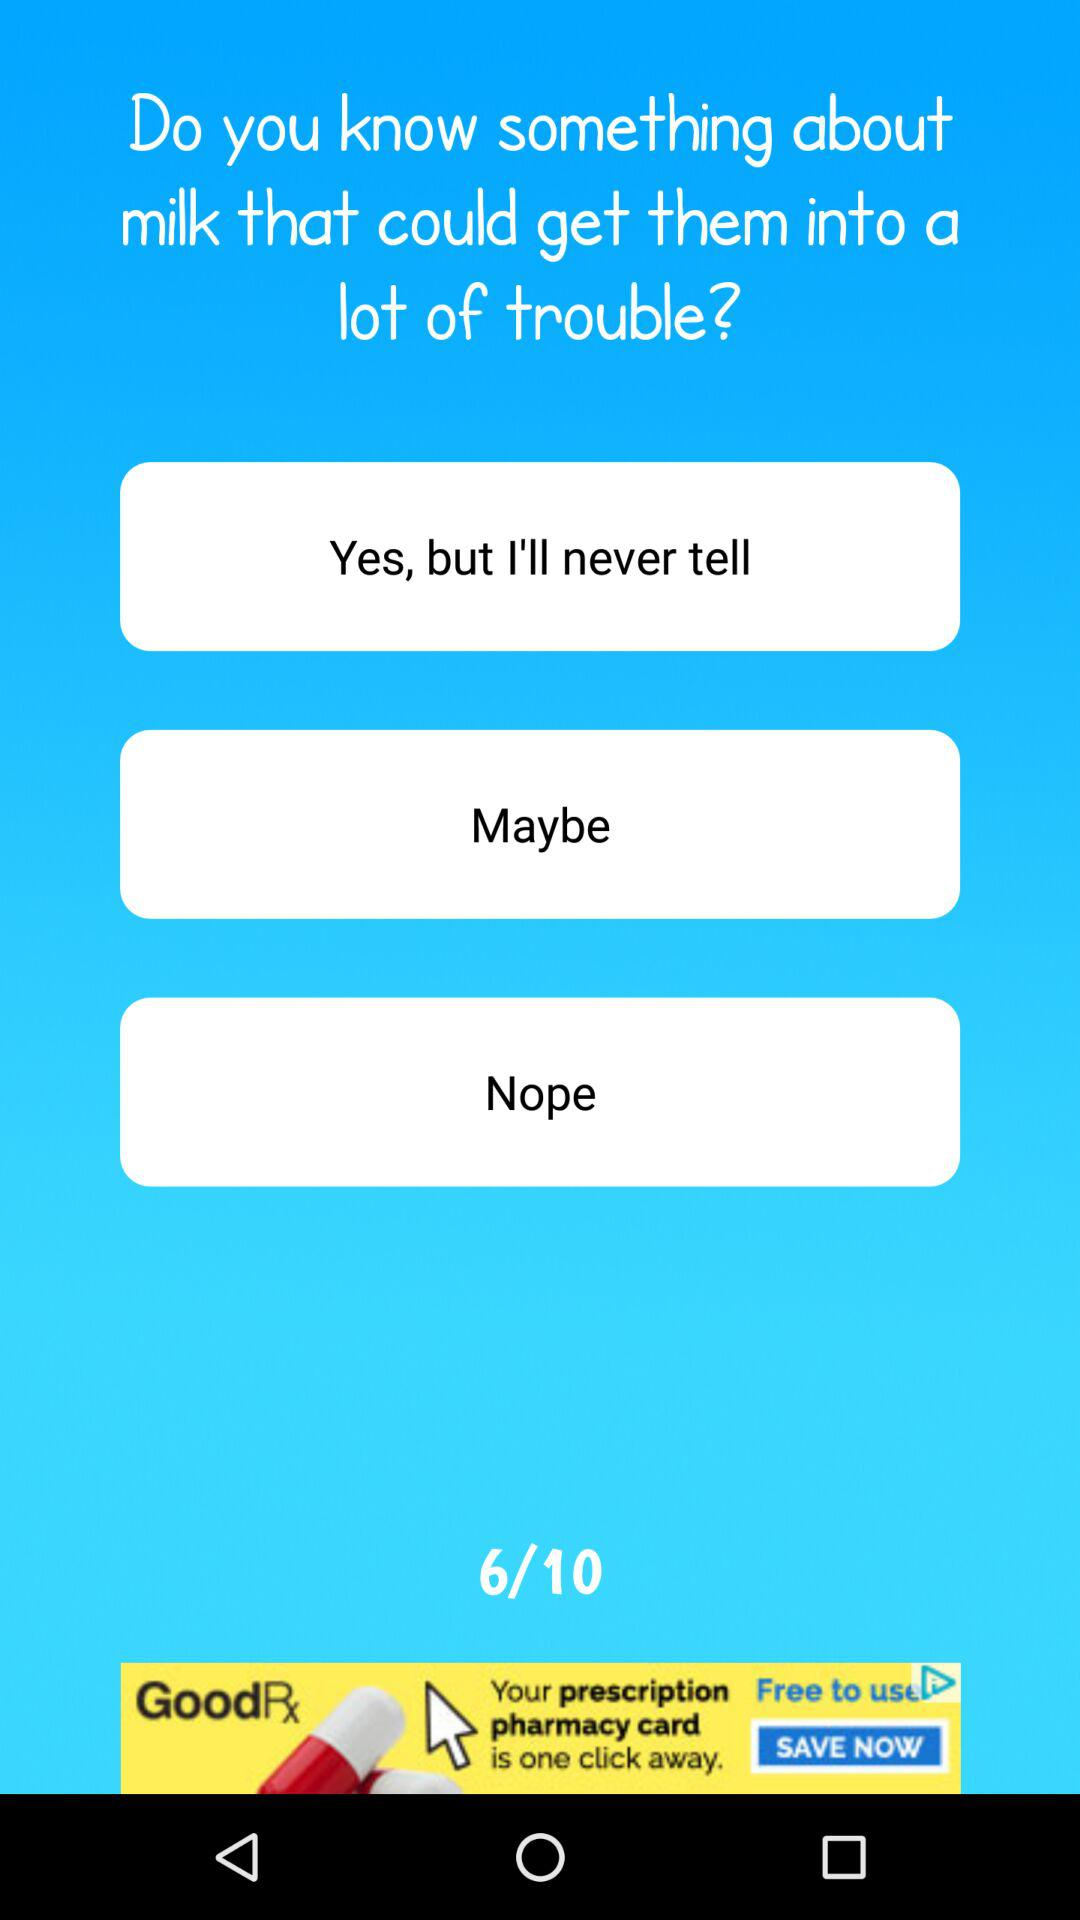How many questions are there in total? There are 10 questions. 